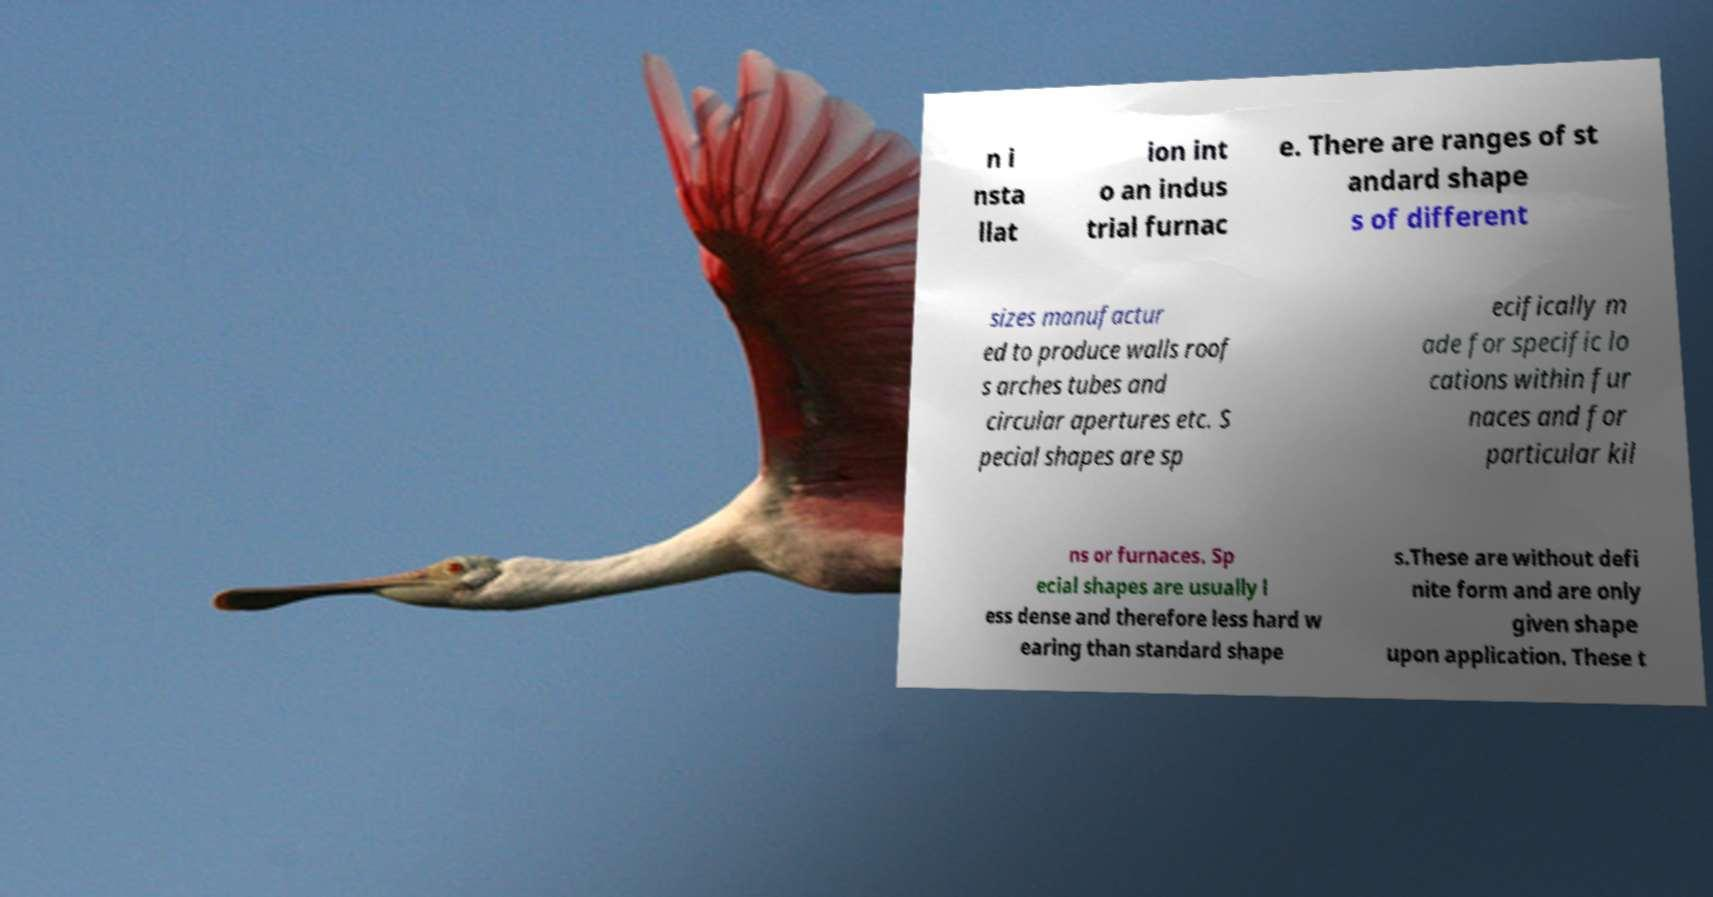I need the written content from this picture converted into text. Can you do that? n i nsta llat ion int o an indus trial furnac e. There are ranges of st andard shape s of different sizes manufactur ed to produce walls roof s arches tubes and circular apertures etc. S pecial shapes are sp ecifically m ade for specific lo cations within fur naces and for particular kil ns or furnaces. Sp ecial shapes are usually l ess dense and therefore less hard w earing than standard shape s.These are without defi nite form and are only given shape upon application. These t 